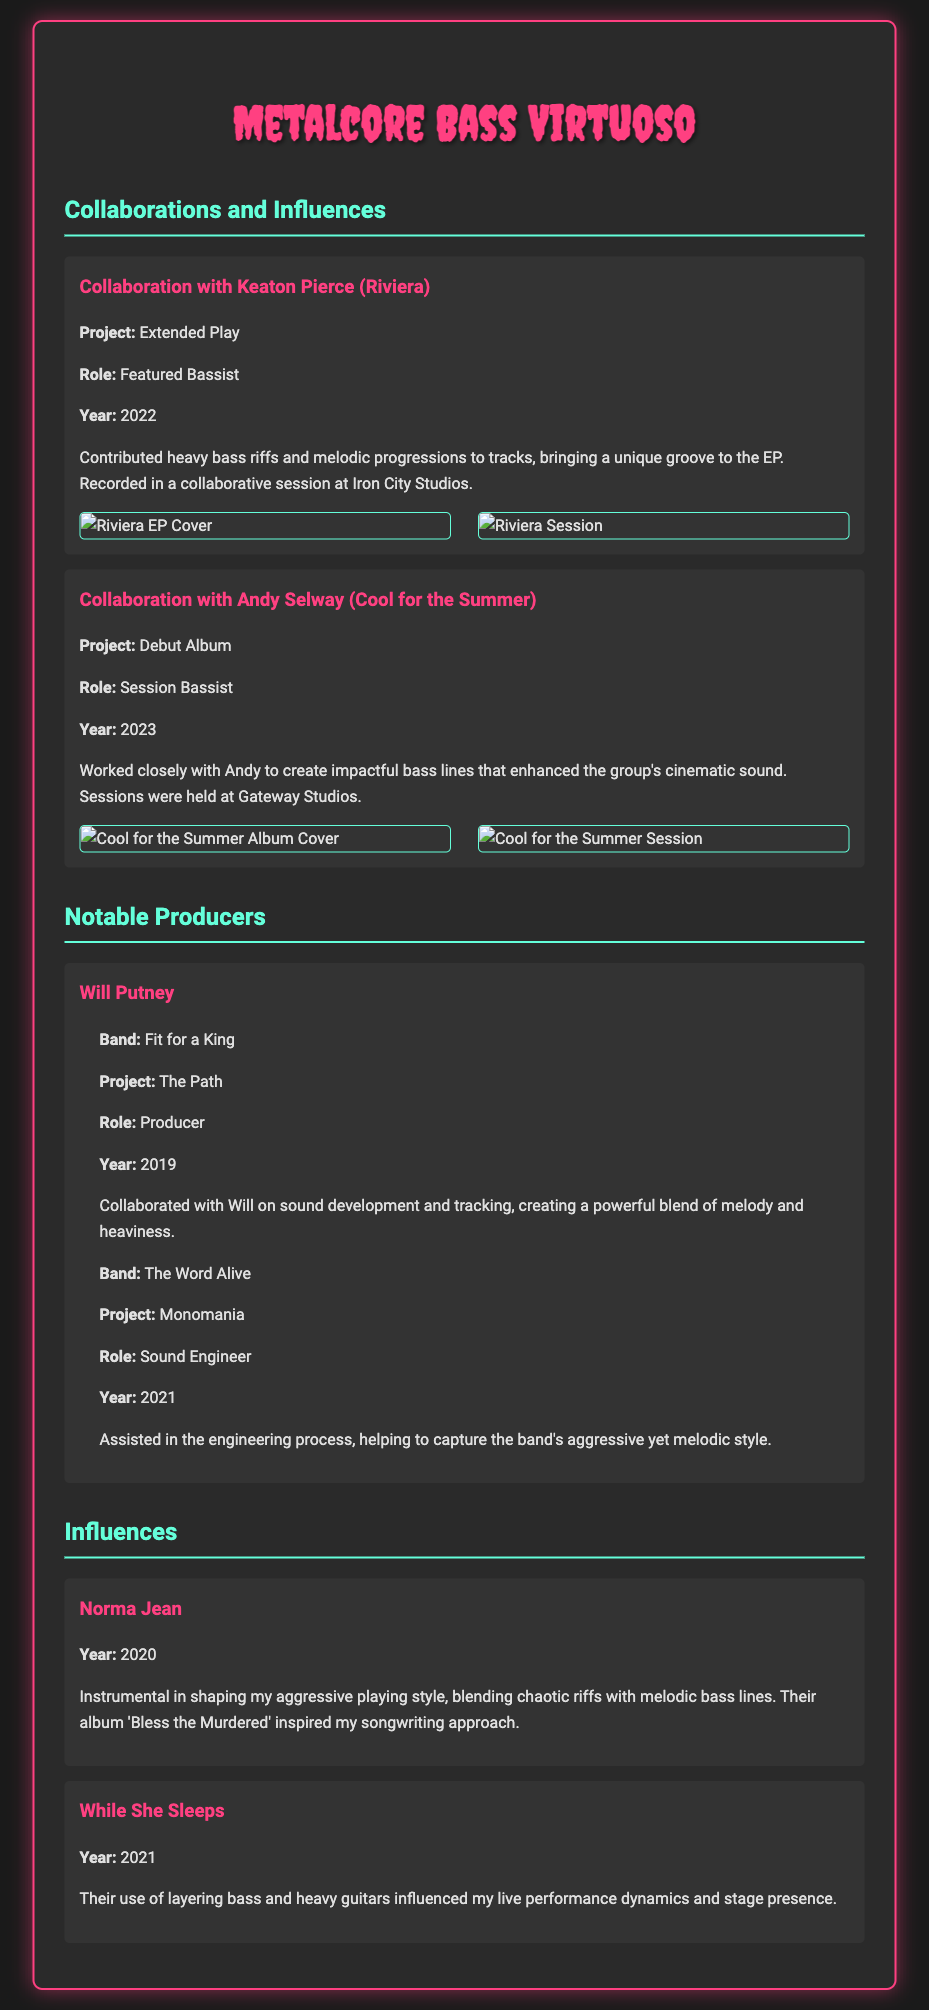What is the name of the artist collaborated with in 2022? The collaboration in 2022 was with Keaton Pierce from Riviera.
Answer: Keaton Pierce What role did you play in the Cool for the Summer album? The role mentioned in the document for the Cool for the Summer album is of a session bassist.
Answer: Session Bassist What year did the collaboration with Andy Selway occur? The collaboration with Andy Selway took place in 2023.
Answer: 2023 Who produced the project "The Path"? The project "The Path" was produced by Will Putney.
Answer: Will Putney Which album influenced your songwriting approach according to the influences section? The album that inspired the songwriting approach is 'Bless the Murdered' by Norma Jean.
Answer: Bless the Murdered What was the project name associated with Will Putney and Fit for a King? The project associated with Will Putney and Fit for a King is called "The Path."
Answer: The Path How did While She Sleeps influence your performance? While She Sleeps influenced the live performance dynamics and stage presence.
Answer: Live performance dynamics What type of projects are highlighted under notable producers? The notable producers section highlights projects related to production and sound engineering.
Answer: Production and sound engineering 